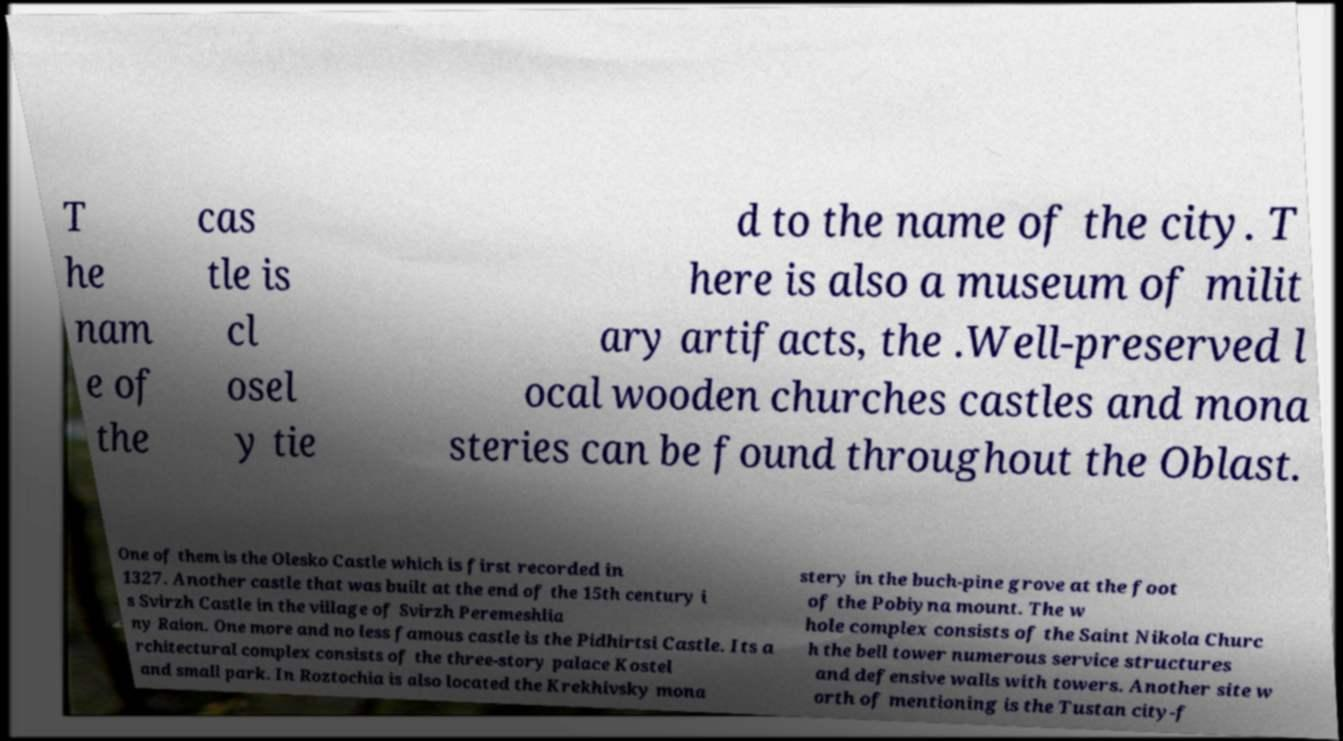Please identify and transcribe the text found in this image. T he nam e of the cas tle is cl osel y tie d to the name of the city. T here is also a museum of milit ary artifacts, the .Well-preserved l ocal wooden churches castles and mona steries can be found throughout the Oblast. One of them is the Olesko Castle which is first recorded in 1327. Another castle that was built at the end of the 15th century i s Svirzh Castle in the village of Svirzh Peremeshlia ny Raion. One more and no less famous castle is the Pidhirtsi Castle. Its a rchitectural complex consists of the three-story palace Kostel and small park. In Roztochia is also located the Krekhivsky mona stery in the buch-pine grove at the foot of the Pobiyna mount. The w hole complex consists of the Saint Nikola Churc h the bell tower numerous service structures and defensive walls with towers. Another site w orth of mentioning is the Tustan city-f 